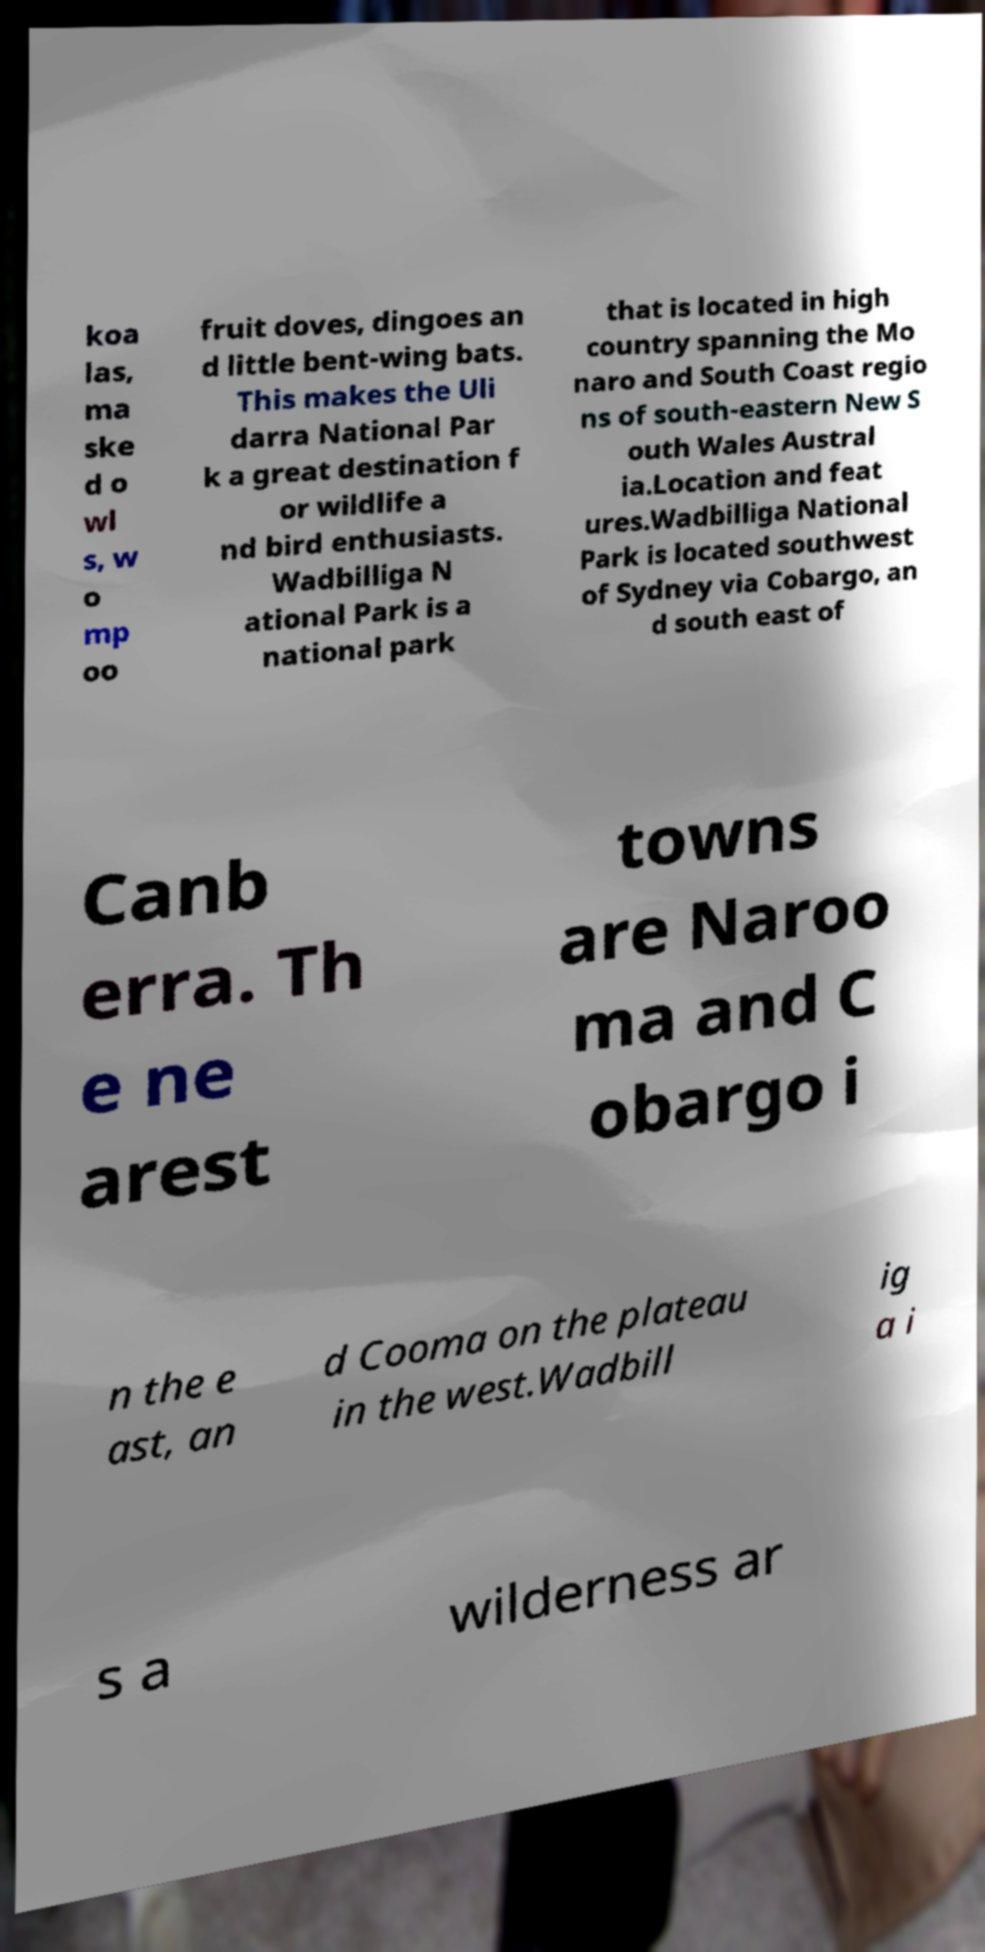Can you accurately transcribe the text from the provided image for me? koa las, ma ske d o wl s, w o mp oo fruit doves, dingoes an d little bent-wing bats. This makes the Uli darra National Par k a great destination f or wildlife a nd bird enthusiasts. Wadbilliga N ational Park is a national park that is located in high country spanning the Mo naro and South Coast regio ns of south-eastern New S outh Wales Austral ia.Location and feat ures.Wadbilliga National Park is located southwest of Sydney via Cobargo, an d south east of Canb erra. Th e ne arest towns are Naroo ma and C obargo i n the e ast, an d Cooma on the plateau in the west.Wadbill ig a i s a wilderness ar 